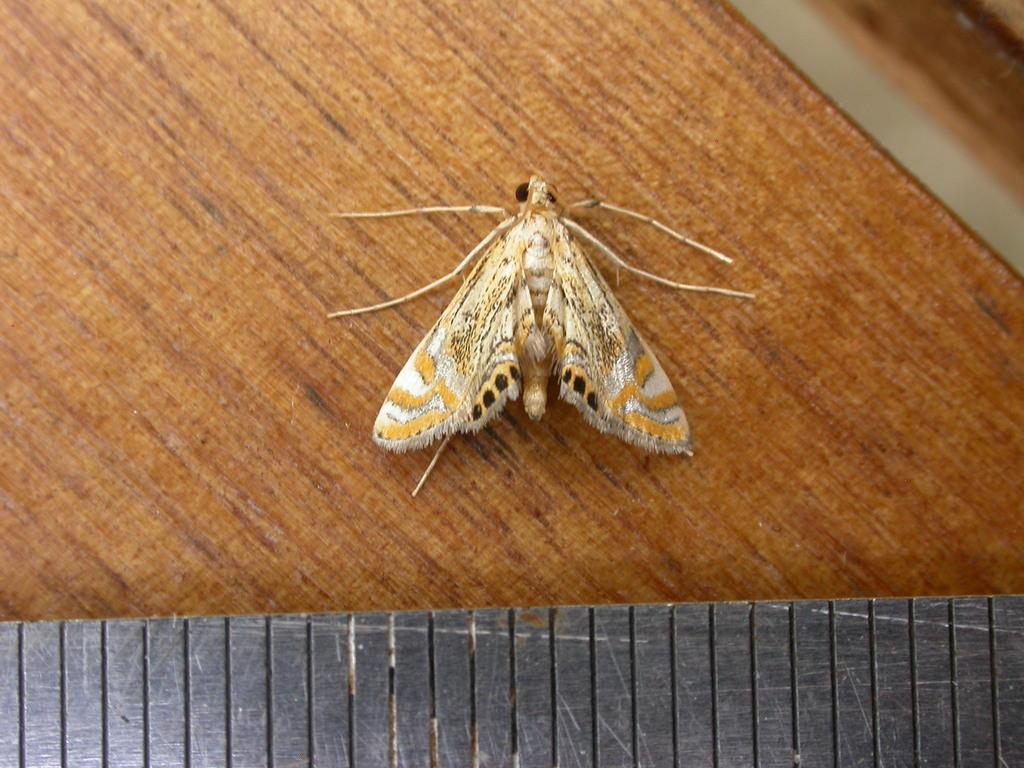How would you summarize this image in a sentence or two? In this image I can see an insect on a wooden object. At the bottom of the image it looks like another wood object. 